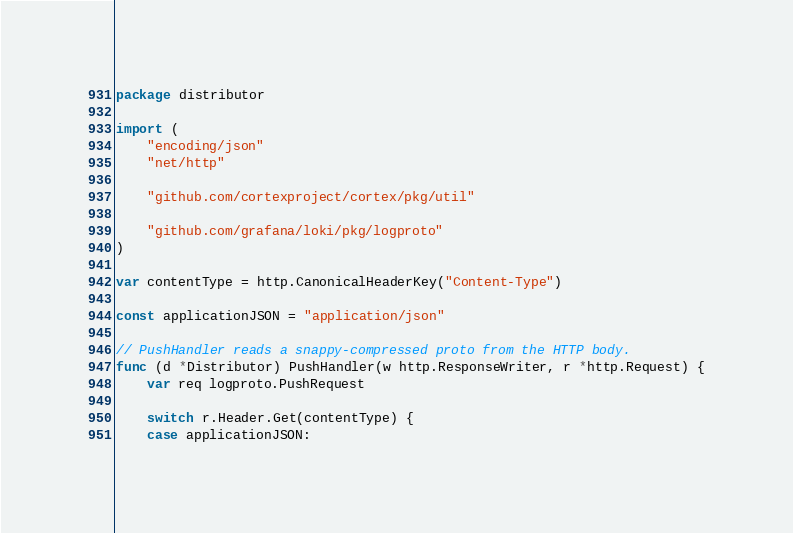<code> <loc_0><loc_0><loc_500><loc_500><_Go_>package distributor

import (
	"encoding/json"
	"net/http"

	"github.com/cortexproject/cortex/pkg/util"

	"github.com/grafana/loki/pkg/logproto"
)

var contentType = http.CanonicalHeaderKey("Content-Type")

const applicationJSON = "application/json"

// PushHandler reads a snappy-compressed proto from the HTTP body.
func (d *Distributor) PushHandler(w http.ResponseWriter, r *http.Request) {
	var req logproto.PushRequest

	switch r.Header.Get(contentType) {
	case applicationJSON:</code> 